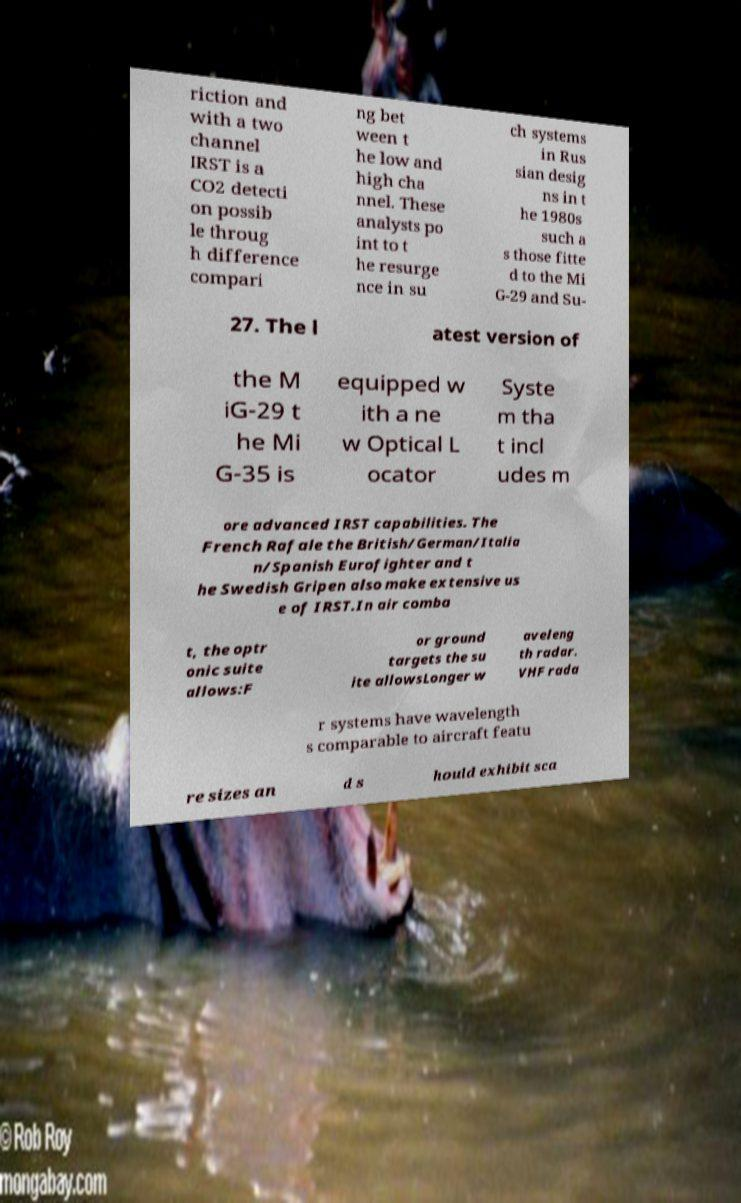There's text embedded in this image that I need extracted. Can you transcribe it verbatim? riction and with a two channel IRST is a CO2 detecti on possib le throug h difference compari ng bet ween t he low and high cha nnel. These analysts po int to t he resurge nce in su ch systems in Rus sian desig ns in t he 1980s such a s those fitte d to the Mi G-29 and Su- 27. The l atest version of the M iG-29 t he Mi G-35 is equipped w ith a ne w Optical L ocator Syste m tha t incl udes m ore advanced IRST capabilities. The French Rafale the British/German/Italia n/Spanish Eurofighter and t he Swedish Gripen also make extensive us e of IRST.In air comba t, the optr onic suite allows:F or ground targets the su ite allowsLonger w aveleng th radar. VHF rada r systems have wavelength s comparable to aircraft featu re sizes an d s hould exhibit sca 